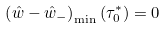<formula> <loc_0><loc_0><loc_500><loc_500>\left ( \hat { w } - \hat { w } _ { - } \right ) _ { \min } \left ( \tau _ { 0 } ^ { * } \right ) = 0</formula> 